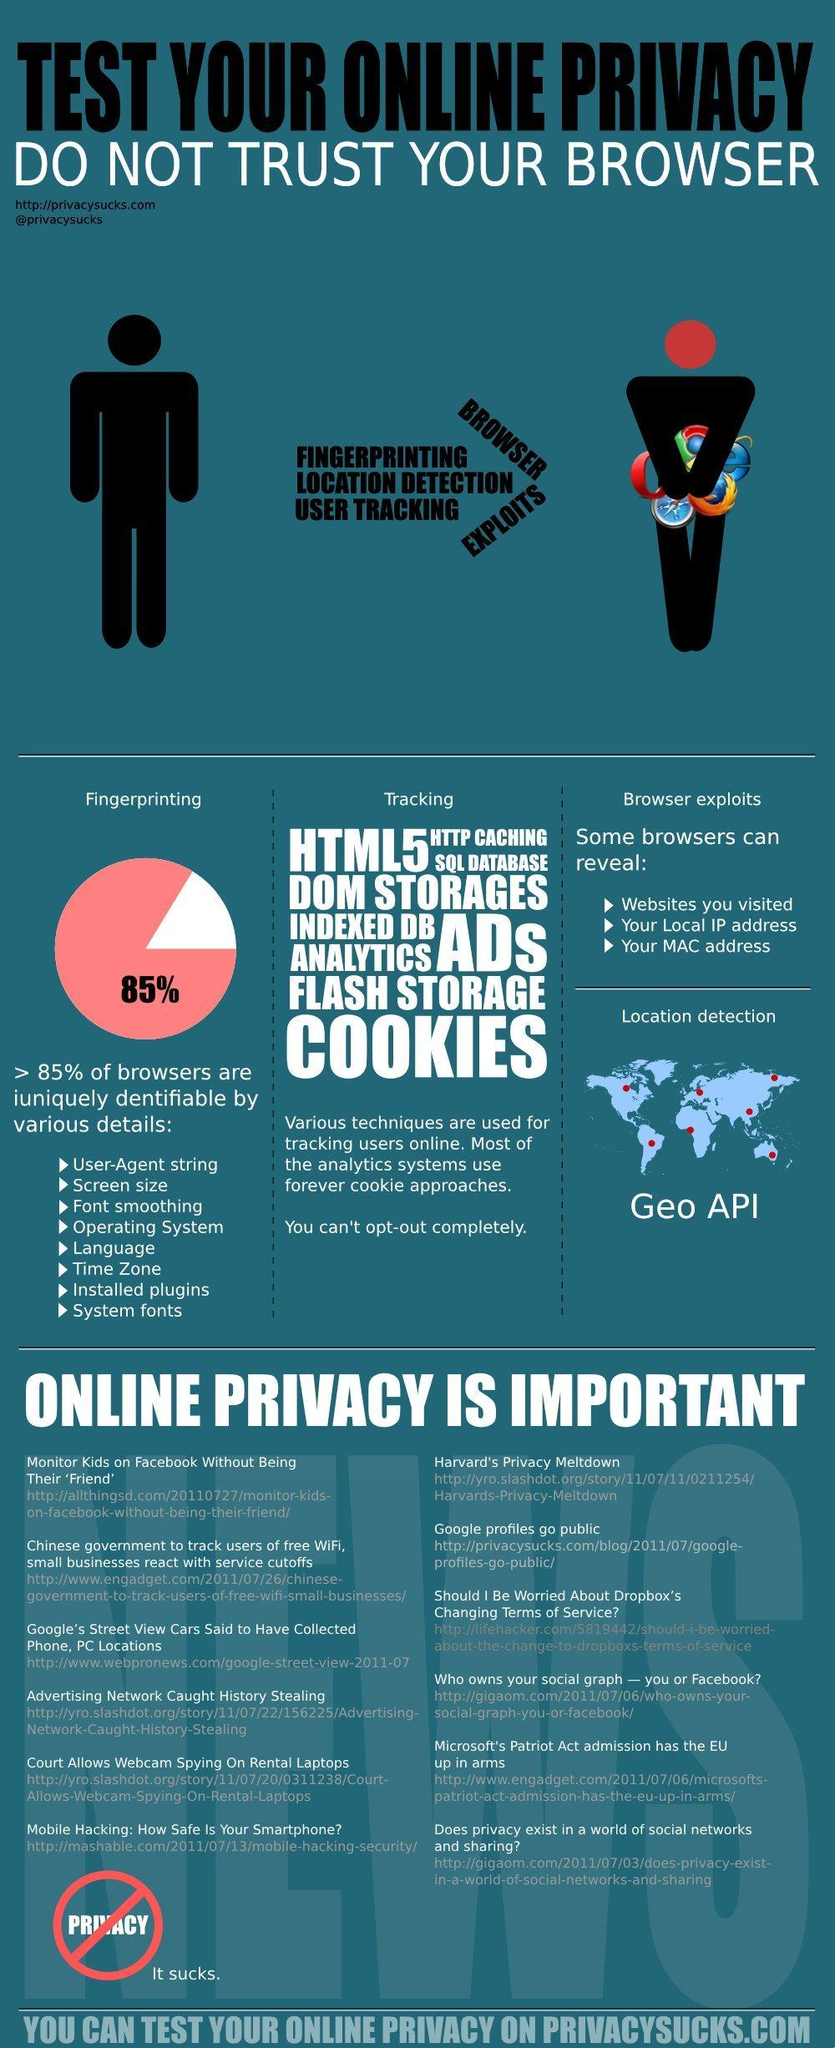Online privacy can be affected by which all factors in addition to browser exploits
Answer the question with a short phrase. Fingerprinting, Location Detection, User Tracking What is written inside the pie chart 85% What does the Geo API do location detection 